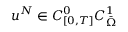<formula> <loc_0><loc_0><loc_500><loc_500>u ^ { N } \in C _ { [ 0 , T ] } ^ { 0 } C _ { \ B a r { \Omega } } ^ { 1 }</formula> 